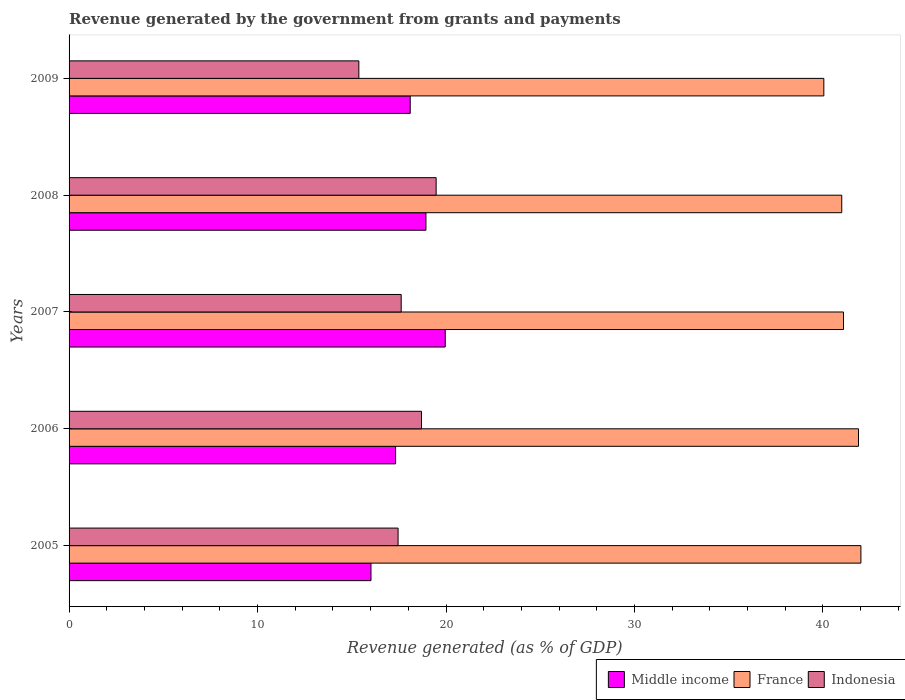How many different coloured bars are there?
Keep it short and to the point. 3. How many groups of bars are there?
Ensure brevity in your answer.  5. Are the number of bars per tick equal to the number of legend labels?
Ensure brevity in your answer.  Yes. How many bars are there on the 4th tick from the top?
Give a very brief answer. 3. What is the label of the 5th group of bars from the top?
Provide a short and direct response. 2005. What is the revenue generated by the government in Middle income in 2009?
Ensure brevity in your answer.  18.1. Across all years, what is the maximum revenue generated by the government in Middle income?
Ensure brevity in your answer.  19.96. Across all years, what is the minimum revenue generated by the government in Indonesia?
Provide a short and direct response. 15.38. In which year was the revenue generated by the government in Indonesia minimum?
Your answer should be compact. 2009. What is the total revenue generated by the government in Indonesia in the graph?
Offer a very short reply. 88.63. What is the difference between the revenue generated by the government in Middle income in 2005 and that in 2006?
Offer a very short reply. -1.31. What is the difference between the revenue generated by the government in Indonesia in 2005 and the revenue generated by the government in France in 2009?
Provide a short and direct response. -22.59. What is the average revenue generated by the government in France per year?
Your answer should be compact. 41.21. In the year 2009, what is the difference between the revenue generated by the government in France and revenue generated by the government in Middle income?
Provide a short and direct response. 21.95. In how many years, is the revenue generated by the government in Middle income greater than 38 %?
Make the answer very short. 0. What is the ratio of the revenue generated by the government in Indonesia in 2007 to that in 2009?
Offer a terse response. 1.15. What is the difference between the highest and the second highest revenue generated by the government in Indonesia?
Provide a succinct answer. 0.78. What is the difference between the highest and the lowest revenue generated by the government in Indonesia?
Ensure brevity in your answer.  4.1. In how many years, is the revenue generated by the government in Middle income greater than the average revenue generated by the government in Middle income taken over all years?
Ensure brevity in your answer.  3. What does the 2nd bar from the top in 2005 represents?
Offer a very short reply. France. Is it the case that in every year, the sum of the revenue generated by the government in France and revenue generated by the government in Middle income is greater than the revenue generated by the government in Indonesia?
Ensure brevity in your answer.  Yes. How many bars are there?
Your answer should be compact. 15. Are all the bars in the graph horizontal?
Your answer should be compact. Yes. Are the values on the major ticks of X-axis written in scientific E-notation?
Provide a short and direct response. No. Does the graph contain any zero values?
Ensure brevity in your answer.  No. How are the legend labels stacked?
Provide a succinct answer. Horizontal. What is the title of the graph?
Your response must be concise. Revenue generated by the government from grants and payments. Does "Paraguay" appear as one of the legend labels in the graph?
Your answer should be compact. No. What is the label or title of the X-axis?
Your answer should be very brief. Revenue generated (as % of GDP). What is the Revenue generated (as % of GDP) of Middle income in 2005?
Ensure brevity in your answer.  16.02. What is the Revenue generated (as % of GDP) of France in 2005?
Keep it short and to the point. 42.01. What is the Revenue generated (as % of GDP) of Indonesia in 2005?
Keep it short and to the point. 17.46. What is the Revenue generated (as % of GDP) of Middle income in 2006?
Offer a terse response. 17.33. What is the Revenue generated (as % of GDP) in France in 2006?
Provide a short and direct response. 41.89. What is the Revenue generated (as % of GDP) of Indonesia in 2006?
Offer a terse response. 18.7. What is the Revenue generated (as % of GDP) in Middle income in 2007?
Give a very brief answer. 19.96. What is the Revenue generated (as % of GDP) in France in 2007?
Give a very brief answer. 41.09. What is the Revenue generated (as % of GDP) in Indonesia in 2007?
Offer a very short reply. 17.62. What is the Revenue generated (as % of GDP) of Middle income in 2008?
Offer a very short reply. 18.94. What is the Revenue generated (as % of GDP) in France in 2008?
Your answer should be compact. 41. What is the Revenue generated (as % of GDP) in Indonesia in 2008?
Make the answer very short. 19.48. What is the Revenue generated (as % of GDP) in Middle income in 2009?
Make the answer very short. 18.1. What is the Revenue generated (as % of GDP) in France in 2009?
Your response must be concise. 40.05. What is the Revenue generated (as % of GDP) in Indonesia in 2009?
Provide a short and direct response. 15.38. Across all years, what is the maximum Revenue generated (as % of GDP) of Middle income?
Give a very brief answer. 19.96. Across all years, what is the maximum Revenue generated (as % of GDP) of France?
Provide a succinct answer. 42.01. Across all years, what is the maximum Revenue generated (as % of GDP) in Indonesia?
Give a very brief answer. 19.48. Across all years, what is the minimum Revenue generated (as % of GDP) in Middle income?
Provide a short and direct response. 16.02. Across all years, what is the minimum Revenue generated (as % of GDP) of France?
Your response must be concise. 40.05. Across all years, what is the minimum Revenue generated (as % of GDP) in Indonesia?
Provide a short and direct response. 15.38. What is the total Revenue generated (as % of GDP) in Middle income in the graph?
Provide a short and direct response. 90.34. What is the total Revenue generated (as % of GDP) of France in the graph?
Provide a short and direct response. 206.04. What is the total Revenue generated (as % of GDP) in Indonesia in the graph?
Your answer should be compact. 88.63. What is the difference between the Revenue generated (as % of GDP) in Middle income in 2005 and that in 2006?
Give a very brief answer. -1.31. What is the difference between the Revenue generated (as % of GDP) in France in 2005 and that in 2006?
Provide a succinct answer. 0.13. What is the difference between the Revenue generated (as % of GDP) of Indonesia in 2005 and that in 2006?
Provide a short and direct response. -1.24. What is the difference between the Revenue generated (as % of GDP) of Middle income in 2005 and that in 2007?
Provide a short and direct response. -3.94. What is the difference between the Revenue generated (as % of GDP) of France in 2005 and that in 2007?
Ensure brevity in your answer.  0.92. What is the difference between the Revenue generated (as % of GDP) in Indonesia in 2005 and that in 2007?
Give a very brief answer. -0.17. What is the difference between the Revenue generated (as % of GDP) of Middle income in 2005 and that in 2008?
Your response must be concise. -2.92. What is the difference between the Revenue generated (as % of GDP) of France in 2005 and that in 2008?
Provide a short and direct response. 1.02. What is the difference between the Revenue generated (as % of GDP) in Indonesia in 2005 and that in 2008?
Your answer should be compact. -2.02. What is the difference between the Revenue generated (as % of GDP) of Middle income in 2005 and that in 2009?
Offer a terse response. -2.08. What is the difference between the Revenue generated (as % of GDP) of France in 2005 and that in 2009?
Offer a terse response. 1.97. What is the difference between the Revenue generated (as % of GDP) of Indonesia in 2005 and that in 2009?
Offer a very short reply. 2.08. What is the difference between the Revenue generated (as % of GDP) in Middle income in 2006 and that in 2007?
Keep it short and to the point. -2.63. What is the difference between the Revenue generated (as % of GDP) in France in 2006 and that in 2007?
Offer a terse response. 0.8. What is the difference between the Revenue generated (as % of GDP) in Indonesia in 2006 and that in 2007?
Offer a very short reply. 1.08. What is the difference between the Revenue generated (as % of GDP) in Middle income in 2006 and that in 2008?
Offer a terse response. -1.61. What is the difference between the Revenue generated (as % of GDP) of France in 2006 and that in 2008?
Your answer should be very brief. 0.89. What is the difference between the Revenue generated (as % of GDP) of Indonesia in 2006 and that in 2008?
Provide a succinct answer. -0.78. What is the difference between the Revenue generated (as % of GDP) in Middle income in 2006 and that in 2009?
Ensure brevity in your answer.  -0.78. What is the difference between the Revenue generated (as % of GDP) of France in 2006 and that in 2009?
Provide a short and direct response. 1.84. What is the difference between the Revenue generated (as % of GDP) of Indonesia in 2006 and that in 2009?
Offer a very short reply. 3.32. What is the difference between the Revenue generated (as % of GDP) in Middle income in 2007 and that in 2008?
Offer a terse response. 1.02. What is the difference between the Revenue generated (as % of GDP) of France in 2007 and that in 2008?
Provide a succinct answer. 0.09. What is the difference between the Revenue generated (as % of GDP) of Indonesia in 2007 and that in 2008?
Give a very brief answer. -1.85. What is the difference between the Revenue generated (as % of GDP) in Middle income in 2007 and that in 2009?
Your answer should be compact. 1.86. What is the difference between the Revenue generated (as % of GDP) of France in 2007 and that in 2009?
Make the answer very short. 1.04. What is the difference between the Revenue generated (as % of GDP) in Indonesia in 2007 and that in 2009?
Offer a terse response. 2.25. What is the difference between the Revenue generated (as % of GDP) of Middle income in 2008 and that in 2009?
Give a very brief answer. 0.83. What is the difference between the Revenue generated (as % of GDP) in France in 2008 and that in 2009?
Keep it short and to the point. 0.95. What is the difference between the Revenue generated (as % of GDP) of Indonesia in 2008 and that in 2009?
Make the answer very short. 4.1. What is the difference between the Revenue generated (as % of GDP) in Middle income in 2005 and the Revenue generated (as % of GDP) in France in 2006?
Offer a very short reply. -25.87. What is the difference between the Revenue generated (as % of GDP) of Middle income in 2005 and the Revenue generated (as % of GDP) of Indonesia in 2006?
Offer a terse response. -2.68. What is the difference between the Revenue generated (as % of GDP) in France in 2005 and the Revenue generated (as % of GDP) in Indonesia in 2006?
Ensure brevity in your answer.  23.31. What is the difference between the Revenue generated (as % of GDP) in Middle income in 2005 and the Revenue generated (as % of GDP) in France in 2007?
Provide a succinct answer. -25.07. What is the difference between the Revenue generated (as % of GDP) of Middle income in 2005 and the Revenue generated (as % of GDP) of Indonesia in 2007?
Your response must be concise. -1.6. What is the difference between the Revenue generated (as % of GDP) in France in 2005 and the Revenue generated (as % of GDP) in Indonesia in 2007?
Your answer should be very brief. 24.39. What is the difference between the Revenue generated (as % of GDP) of Middle income in 2005 and the Revenue generated (as % of GDP) of France in 2008?
Your answer should be compact. -24.98. What is the difference between the Revenue generated (as % of GDP) of Middle income in 2005 and the Revenue generated (as % of GDP) of Indonesia in 2008?
Keep it short and to the point. -3.46. What is the difference between the Revenue generated (as % of GDP) of France in 2005 and the Revenue generated (as % of GDP) of Indonesia in 2008?
Keep it short and to the point. 22.54. What is the difference between the Revenue generated (as % of GDP) in Middle income in 2005 and the Revenue generated (as % of GDP) in France in 2009?
Your answer should be compact. -24.03. What is the difference between the Revenue generated (as % of GDP) in Middle income in 2005 and the Revenue generated (as % of GDP) in Indonesia in 2009?
Offer a very short reply. 0.64. What is the difference between the Revenue generated (as % of GDP) of France in 2005 and the Revenue generated (as % of GDP) of Indonesia in 2009?
Keep it short and to the point. 26.64. What is the difference between the Revenue generated (as % of GDP) of Middle income in 2006 and the Revenue generated (as % of GDP) of France in 2007?
Your response must be concise. -23.77. What is the difference between the Revenue generated (as % of GDP) in Middle income in 2006 and the Revenue generated (as % of GDP) in Indonesia in 2007?
Provide a succinct answer. -0.3. What is the difference between the Revenue generated (as % of GDP) in France in 2006 and the Revenue generated (as % of GDP) in Indonesia in 2007?
Make the answer very short. 24.26. What is the difference between the Revenue generated (as % of GDP) in Middle income in 2006 and the Revenue generated (as % of GDP) in France in 2008?
Ensure brevity in your answer.  -23.67. What is the difference between the Revenue generated (as % of GDP) in Middle income in 2006 and the Revenue generated (as % of GDP) in Indonesia in 2008?
Provide a succinct answer. -2.15. What is the difference between the Revenue generated (as % of GDP) of France in 2006 and the Revenue generated (as % of GDP) of Indonesia in 2008?
Your answer should be compact. 22.41. What is the difference between the Revenue generated (as % of GDP) of Middle income in 2006 and the Revenue generated (as % of GDP) of France in 2009?
Give a very brief answer. -22.72. What is the difference between the Revenue generated (as % of GDP) in Middle income in 2006 and the Revenue generated (as % of GDP) in Indonesia in 2009?
Offer a very short reply. 1.95. What is the difference between the Revenue generated (as % of GDP) of France in 2006 and the Revenue generated (as % of GDP) of Indonesia in 2009?
Your answer should be compact. 26.51. What is the difference between the Revenue generated (as % of GDP) in Middle income in 2007 and the Revenue generated (as % of GDP) in France in 2008?
Offer a very short reply. -21.04. What is the difference between the Revenue generated (as % of GDP) in Middle income in 2007 and the Revenue generated (as % of GDP) in Indonesia in 2008?
Make the answer very short. 0.48. What is the difference between the Revenue generated (as % of GDP) in France in 2007 and the Revenue generated (as % of GDP) in Indonesia in 2008?
Offer a very short reply. 21.61. What is the difference between the Revenue generated (as % of GDP) of Middle income in 2007 and the Revenue generated (as % of GDP) of France in 2009?
Ensure brevity in your answer.  -20.09. What is the difference between the Revenue generated (as % of GDP) of Middle income in 2007 and the Revenue generated (as % of GDP) of Indonesia in 2009?
Provide a short and direct response. 4.58. What is the difference between the Revenue generated (as % of GDP) of France in 2007 and the Revenue generated (as % of GDP) of Indonesia in 2009?
Offer a terse response. 25.72. What is the difference between the Revenue generated (as % of GDP) of Middle income in 2008 and the Revenue generated (as % of GDP) of France in 2009?
Ensure brevity in your answer.  -21.11. What is the difference between the Revenue generated (as % of GDP) in Middle income in 2008 and the Revenue generated (as % of GDP) in Indonesia in 2009?
Give a very brief answer. 3.56. What is the difference between the Revenue generated (as % of GDP) in France in 2008 and the Revenue generated (as % of GDP) in Indonesia in 2009?
Your answer should be compact. 25.62. What is the average Revenue generated (as % of GDP) of Middle income per year?
Keep it short and to the point. 18.07. What is the average Revenue generated (as % of GDP) of France per year?
Give a very brief answer. 41.21. What is the average Revenue generated (as % of GDP) of Indonesia per year?
Provide a succinct answer. 17.73. In the year 2005, what is the difference between the Revenue generated (as % of GDP) of Middle income and Revenue generated (as % of GDP) of France?
Provide a succinct answer. -26. In the year 2005, what is the difference between the Revenue generated (as % of GDP) in Middle income and Revenue generated (as % of GDP) in Indonesia?
Provide a short and direct response. -1.44. In the year 2005, what is the difference between the Revenue generated (as % of GDP) in France and Revenue generated (as % of GDP) in Indonesia?
Give a very brief answer. 24.56. In the year 2006, what is the difference between the Revenue generated (as % of GDP) in Middle income and Revenue generated (as % of GDP) in France?
Provide a short and direct response. -24.56. In the year 2006, what is the difference between the Revenue generated (as % of GDP) of Middle income and Revenue generated (as % of GDP) of Indonesia?
Offer a very short reply. -1.37. In the year 2006, what is the difference between the Revenue generated (as % of GDP) of France and Revenue generated (as % of GDP) of Indonesia?
Give a very brief answer. 23.19. In the year 2007, what is the difference between the Revenue generated (as % of GDP) of Middle income and Revenue generated (as % of GDP) of France?
Provide a succinct answer. -21.13. In the year 2007, what is the difference between the Revenue generated (as % of GDP) in Middle income and Revenue generated (as % of GDP) in Indonesia?
Give a very brief answer. 2.34. In the year 2007, what is the difference between the Revenue generated (as % of GDP) in France and Revenue generated (as % of GDP) in Indonesia?
Your response must be concise. 23.47. In the year 2008, what is the difference between the Revenue generated (as % of GDP) in Middle income and Revenue generated (as % of GDP) in France?
Offer a very short reply. -22.06. In the year 2008, what is the difference between the Revenue generated (as % of GDP) in Middle income and Revenue generated (as % of GDP) in Indonesia?
Your response must be concise. -0.54. In the year 2008, what is the difference between the Revenue generated (as % of GDP) in France and Revenue generated (as % of GDP) in Indonesia?
Offer a terse response. 21.52. In the year 2009, what is the difference between the Revenue generated (as % of GDP) of Middle income and Revenue generated (as % of GDP) of France?
Your answer should be compact. -21.95. In the year 2009, what is the difference between the Revenue generated (as % of GDP) of Middle income and Revenue generated (as % of GDP) of Indonesia?
Keep it short and to the point. 2.73. In the year 2009, what is the difference between the Revenue generated (as % of GDP) of France and Revenue generated (as % of GDP) of Indonesia?
Give a very brief answer. 24.67. What is the ratio of the Revenue generated (as % of GDP) of Middle income in 2005 to that in 2006?
Your answer should be very brief. 0.92. What is the ratio of the Revenue generated (as % of GDP) of France in 2005 to that in 2006?
Offer a terse response. 1. What is the ratio of the Revenue generated (as % of GDP) of Indonesia in 2005 to that in 2006?
Your answer should be very brief. 0.93. What is the ratio of the Revenue generated (as % of GDP) of Middle income in 2005 to that in 2007?
Your response must be concise. 0.8. What is the ratio of the Revenue generated (as % of GDP) of France in 2005 to that in 2007?
Offer a terse response. 1.02. What is the ratio of the Revenue generated (as % of GDP) in Indonesia in 2005 to that in 2007?
Provide a short and direct response. 0.99. What is the ratio of the Revenue generated (as % of GDP) of Middle income in 2005 to that in 2008?
Your answer should be compact. 0.85. What is the ratio of the Revenue generated (as % of GDP) in France in 2005 to that in 2008?
Your answer should be compact. 1.02. What is the ratio of the Revenue generated (as % of GDP) in Indonesia in 2005 to that in 2008?
Your answer should be compact. 0.9. What is the ratio of the Revenue generated (as % of GDP) in Middle income in 2005 to that in 2009?
Your answer should be compact. 0.89. What is the ratio of the Revenue generated (as % of GDP) of France in 2005 to that in 2009?
Offer a very short reply. 1.05. What is the ratio of the Revenue generated (as % of GDP) in Indonesia in 2005 to that in 2009?
Your answer should be very brief. 1.14. What is the ratio of the Revenue generated (as % of GDP) in Middle income in 2006 to that in 2007?
Give a very brief answer. 0.87. What is the ratio of the Revenue generated (as % of GDP) of France in 2006 to that in 2007?
Ensure brevity in your answer.  1.02. What is the ratio of the Revenue generated (as % of GDP) in Indonesia in 2006 to that in 2007?
Keep it short and to the point. 1.06. What is the ratio of the Revenue generated (as % of GDP) in Middle income in 2006 to that in 2008?
Your answer should be compact. 0.91. What is the ratio of the Revenue generated (as % of GDP) of France in 2006 to that in 2008?
Give a very brief answer. 1.02. What is the ratio of the Revenue generated (as % of GDP) in Indonesia in 2006 to that in 2008?
Offer a very short reply. 0.96. What is the ratio of the Revenue generated (as % of GDP) in Middle income in 2006 to that in 2009?
Your answer should be compact. 0.96. What is the ratio of the Revenue generated (as % of GDP) of France in 2006 to that in 2009?
Provide a succinct answer. 1.05. What is the ratio of the Revenue generated (as % of GDP) of Indonesia in 2006 to that in 2009?
Offer a terse response. 1.22. What is the ratio of the Revenue generated (as % of GDP) of Middle income in 2007 to that in 2008?
Ensure brevity in your answer.  1.05. What is the ratio of the Revenue generated (as % of GDP) of France in 2007 to that in 2008?
Your response must be concise. 1. What is the ratio of the Revenue generated (as % of GDP) in Indonesia in 2007 to that in 2008?
Your answer should be very brief. 0.9. What is the ratio of the Revenue generated (as % of GDP) of Middle income in 2007 to that in 2009?
Make the answer very short. 1.1. What is the ratio of the Revenue generated (as % of GDP) of France in 2007 to that in 2009?
Provide a short and direct response. 1.03. What is the ratio of the Revenue generated (as % of GDP) of Indonesia in 2007 to that in 2009?
Provide a short and direct response. 1.15. What is the ratio of the Revenue generated (as % of GDP) in Middle income in 2008 to that in 2009?
Ensure brevity in your answer.  1.05. What is the ratio of the Revenue generated (as % of GDP) in France in 2008 to that in 2009?
Offer a very short reply. 1.02. What is the ratio of the Revenue generated (as % of GDP) of Indonesia in 2008 to that in 2009?
Offer a very short reply. 1.27. What is the difference between the highest and the second highest Revenue generated (as % of GDP) in Middle income?
Give a very brief answer. 1.02. What is the difference between the highest and the second highest Revenue generated (as % of GDP) of France?
Your answer should be very brief. 0.13. What is the difference between the highest and the second highest Revenue generated (as % of GDP) of Indonesia?
Your response must be concise. 0.78. What is the difference between the highest and the lowest Revenue generated (as % of GDP) of Middle income?
Your answer should be compact. 3.94. What is the difference between the highest and the lowest Revenue generated (as % of GDP) in France?
Your answer should be compact. 1.97. What is the difference between the highest and the lowest Revenue generated (as % of GDP) of Indonesia?
Provide a succinct answer. 4.1. 